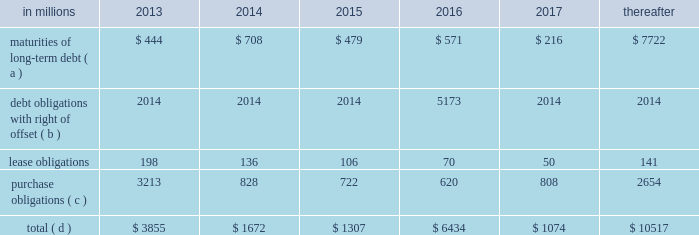Through current cash balances and cash from oper- ations .
Additionally , the company has existing credit facilities totaling $ 2.5 billion .
The company was in compliance with all its debt covenants at december 31 , 2012 .
The company 2019s financial covenants require the maintenance of a minimum net worth of $ 9 billion and a total debt-to- capital ratio of less than 60% ( 60 % ) .
Net worth is defined as the sum of common stock , paid-in capital and retained earnings , less treasury stock plus any cumulative goodwill impairment charges .
The calcu- lation also excludes accumulated other compre- hensive income/loss and nonrecourse financial liabilities of special purpose entities .
The total debt- to-capital ratio is defined as total debt divided by the sum of total debt plus net worth .
At december 31 , 2012 , international paper 2019s net worth was $ 13.9 bil- lion , and the total-debt-to-capital ratio was 42% ( 42 % ) .
The company will continue to rely upon debt and capital markets for the majority of any necessary long-term funding not provided by operating cash flows .
Funding decisions will be guided by our capi- tal structure planning objectives .
The primary goals of the company 2019s capital structure planning are to maximize financial flexibility and preserve liquidity while reducing interest expense .
The majority of international paper 2019s debt is accessed through global public capital markets where we have a wide base of investors .
Maintaining an investment grade credit rating is an important element of international paper 2019s financing strategy .
At december 31 , 2012 , the company held long-term credit ratings of bbb ( stable outlook ) and baa3 ( stable outlook ) by s&p and moody 2019s , respectively .
Contractual obligations for future payments under existing debt and lease commitments and purchase obligations at december 31 , 2012 , were as follows: .
( a ) total debt includes scheduled principal payments only .
( b ) represents debt obligations borrowed from non-consolidated variable interest entities for which international paper has , and intends to effect , a legal right to offset these obligations with investments held in the entities .
Accordingly , in its con- solidated balance sheet at december 31 , 2012 , international paper has offset approximately $ 5.2 billion of interests in the entities against this $ 5.2 billion of debt obligations held by the entities ( see note 11 variable interest entities and preferred securities of subsidiaries on pages 69 through 72 in item 8 .
Financial statements and supplementary data ) .
( c ) includes $ 3.6 billion relating to fiber supply agreements entered into at the time of the 2006 transformation plan forest- land sales and in conjunction with the 2008 acquisition of weyerhaeuser company 2019s containerboard , packaging and recycling business .
( d ) not included in the above table due to the uncertainty as to the amount and timing of the payment are unrecognized tax bene- fits of approximately $ 620 million .
We consider the undistributed earnings of our for- eign subsidiaries as of december 31 , 2012 , to be indefinitely reinvested and , accordingly , no u.s .
Income taxes have been provided thereon .
As of december 31 , 2012 , the amount of cash associated with indefinitely reinvested foreign earnings was approximately $ 840 million .
We do not anticipate the need to repatriate funds to the united states to sat- isfy domestic liquidity needs arising in the ordinary course of business , including liquidity needs asso- ciated with our domestic debt service requirements .
Pension obligations and funding at december 31 , 2012 , the projected benefit obliga- tion for the company 2019s u.s .
Defined benefit plans determined under u.s .
Gaap was approximately $ 4.1 billion higher than the fair value of plan assets .
Approximately $ 3.7 billion of this amount relates to plans that are subject to minimum funding require- ments .
Under current irs funding rules , the calcu- lation of minimum funding requirements differs from the calculation of the present value of plan benefits ( the projected benefit obligation ) for accounting purposes .
In december 2008 , the worker , retiree and employer recovery act of 2008 ( wera ) was passed by the u.s .
Congress which provided for pension funding relief and technical corrections .
Funding contributions depend on the funding method selected by the company , and the timing of its implementation , as well as on actual demo- graphic data and the targeted funding level .
The company continually reassesses the amount and timing of any discretionary contributions and elected to make voluntary contributions totaling $ 44 million and $ 300 million for the years ended december 31 , 2012 and 2011 , respectively .
At this time , we expect that required contributions to its plans in 2013 will be approximately $ 31 million , although the company may elect to make future voluntary contributions .
The timing and amount of future contributions , which could be material , will depend on a number of factors , including the actual earnings and changes in values of plan assets and changes in interest rates .
Ilim holding s.a .
Shareholder 2019s agreement in october 2007 , in connection with the for- mation of the ilim holding s.a .
Joint venture , international paper entered into a share- holder 2019s agreement that includes provisions relating to the reconciliation of disputes among the partners .
This agreement provides that at .
In 2013 what was the percent of the maturities of long term debt of the total contractual obligations for future payments under existing debt and lease commitments and purchase obligations at december 31 , 2012? 
Computations: (444 / 3855)
Answer: 0.11518. 